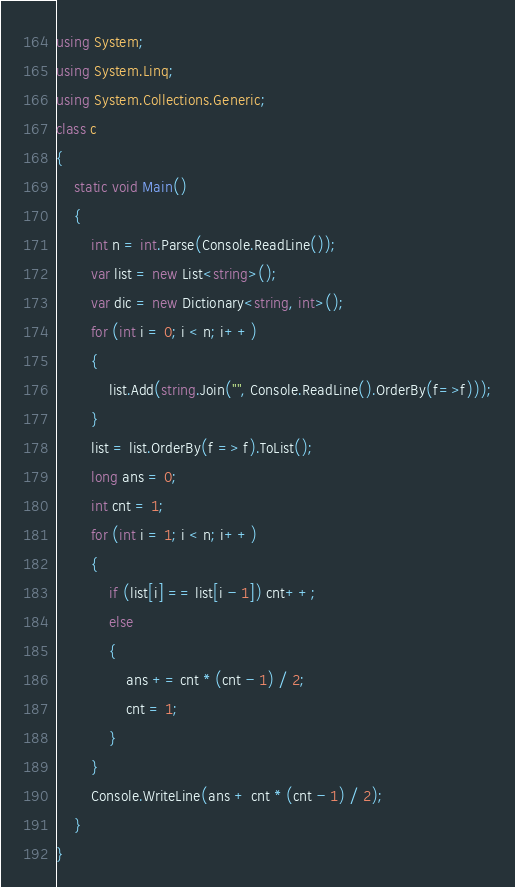Convert code to text. <code><loc_0><loc_0><loc_500><loc_500><_C#_>using System;
using System.Linq;
using System.Collections.Generic;
class c
{
    static void Main()
    {
        int n = int.Parse(Console.ReadLine());
        var list = new List<string>();
        var dic = new Dictionary<string, int>();
        for (int i = 0; i < n; i++)
        {
            list.Add(string.Join("", Console.ReadLine().OrderBy(f=>f)));
        }
        list = list.OrderBy(f => f).ToList();
        long ans = 0;
        int cnt = 1;
        for (int i = 1; i < n; i++)
        {
            if (list[i] == list[i - 1]) cnt++;
            else
            {
                ans += cnt * (cnt - 1) / 2;
                cnt = 1;
            }
        }
        Console.WriteLine(ans + cnt * (cnt - 1) / 2);
    }
}</code> 